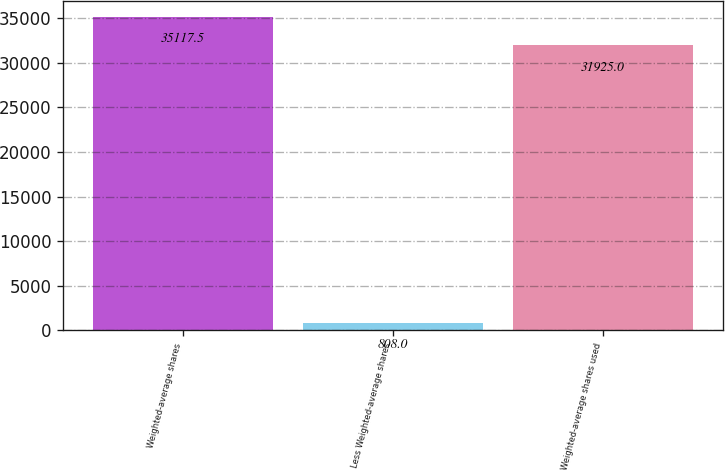<chart> <loc_0><loc_0><loc_500><loc_500><bar_chart><fcel>Weighted-average shares<fcel>Less Weighted-average shares<fcel>Weighted-average shares used<nl><fcel>35117.5<fcel>808<fcel>31925<nl></chart> 